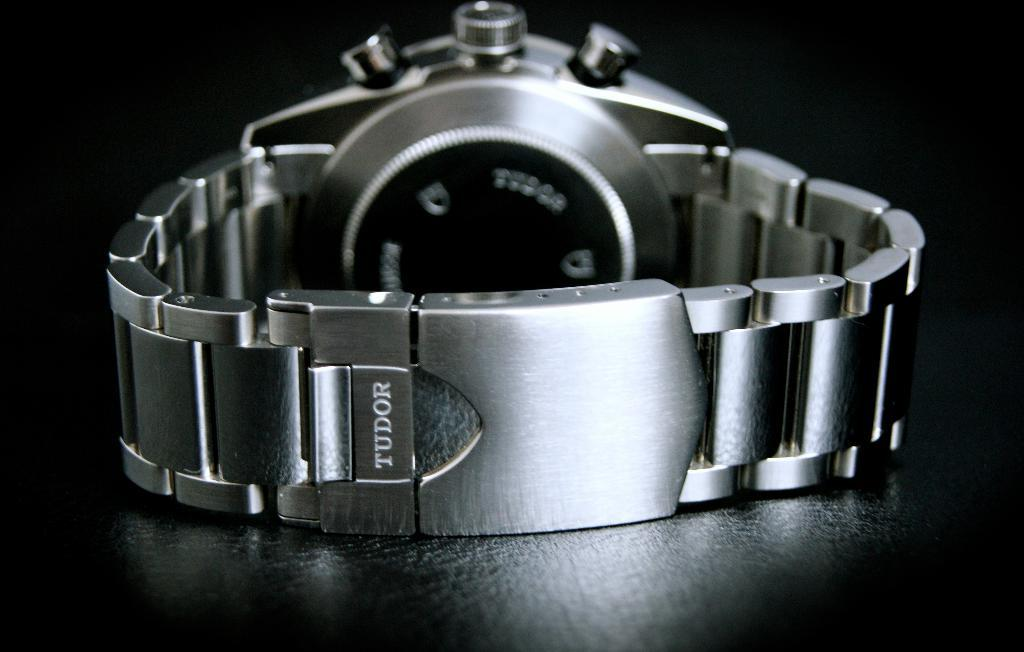<image>
Render a clear and concise summary of the photo. A Tudor brand watch is displayed, prominently showing the wristband. 